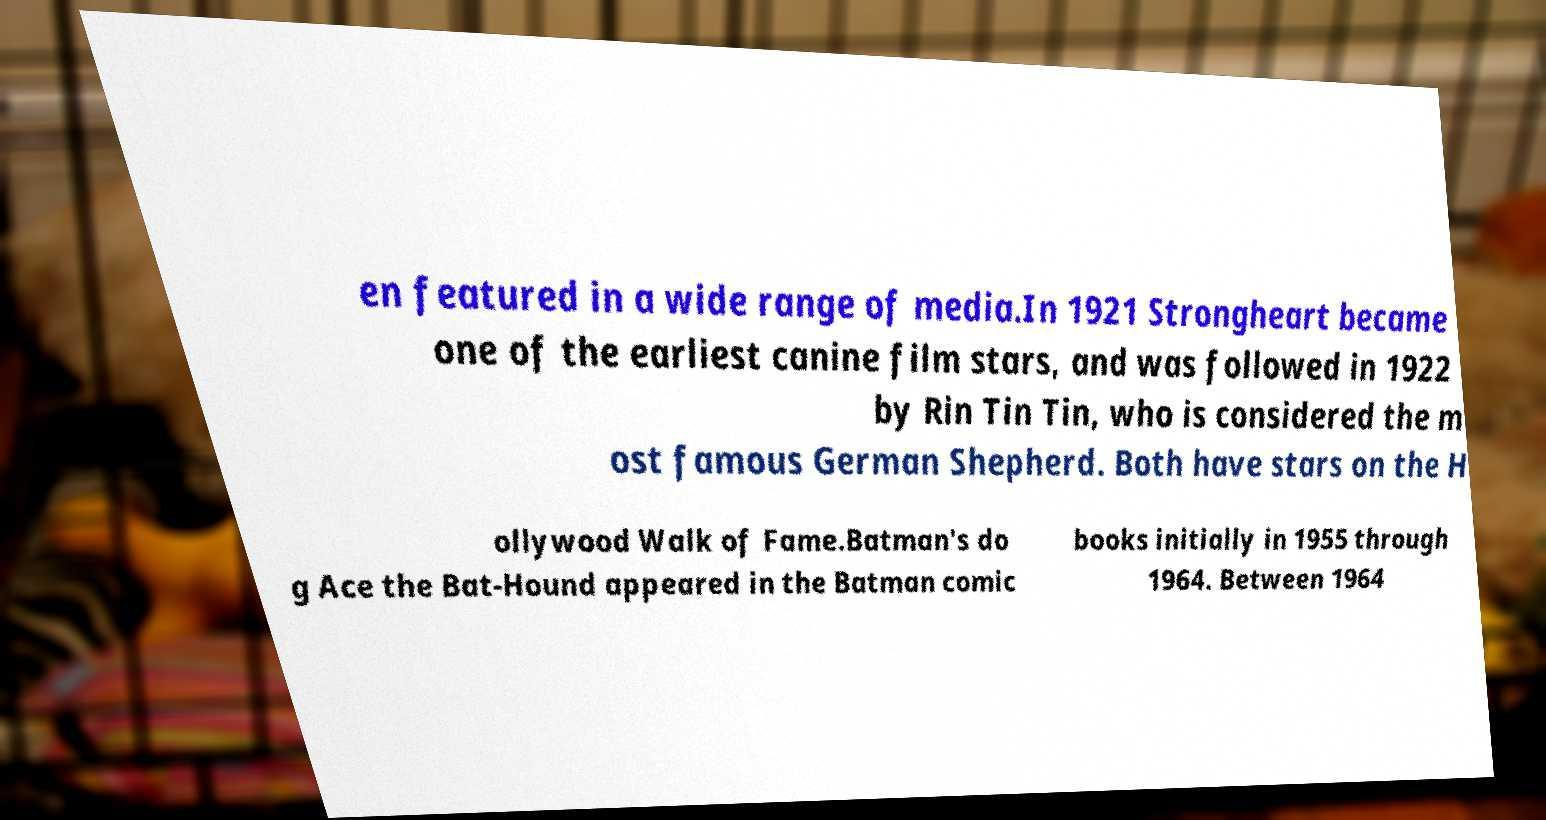I need the written content from this picture converted into text. Can you do that? en featured in a wide range of media.In 1921 Strongheart became one of the earliest canine film stars, and was followed in 1922 by Rin Tin Tin, who is considered the m ost famous German Shepherd. Both have stars on the H ollywood Walk of Fame.Batman's do g Ace the Bat-Hound appeared in the Batman comic books initially in 1955 through 1964. Between 1964 